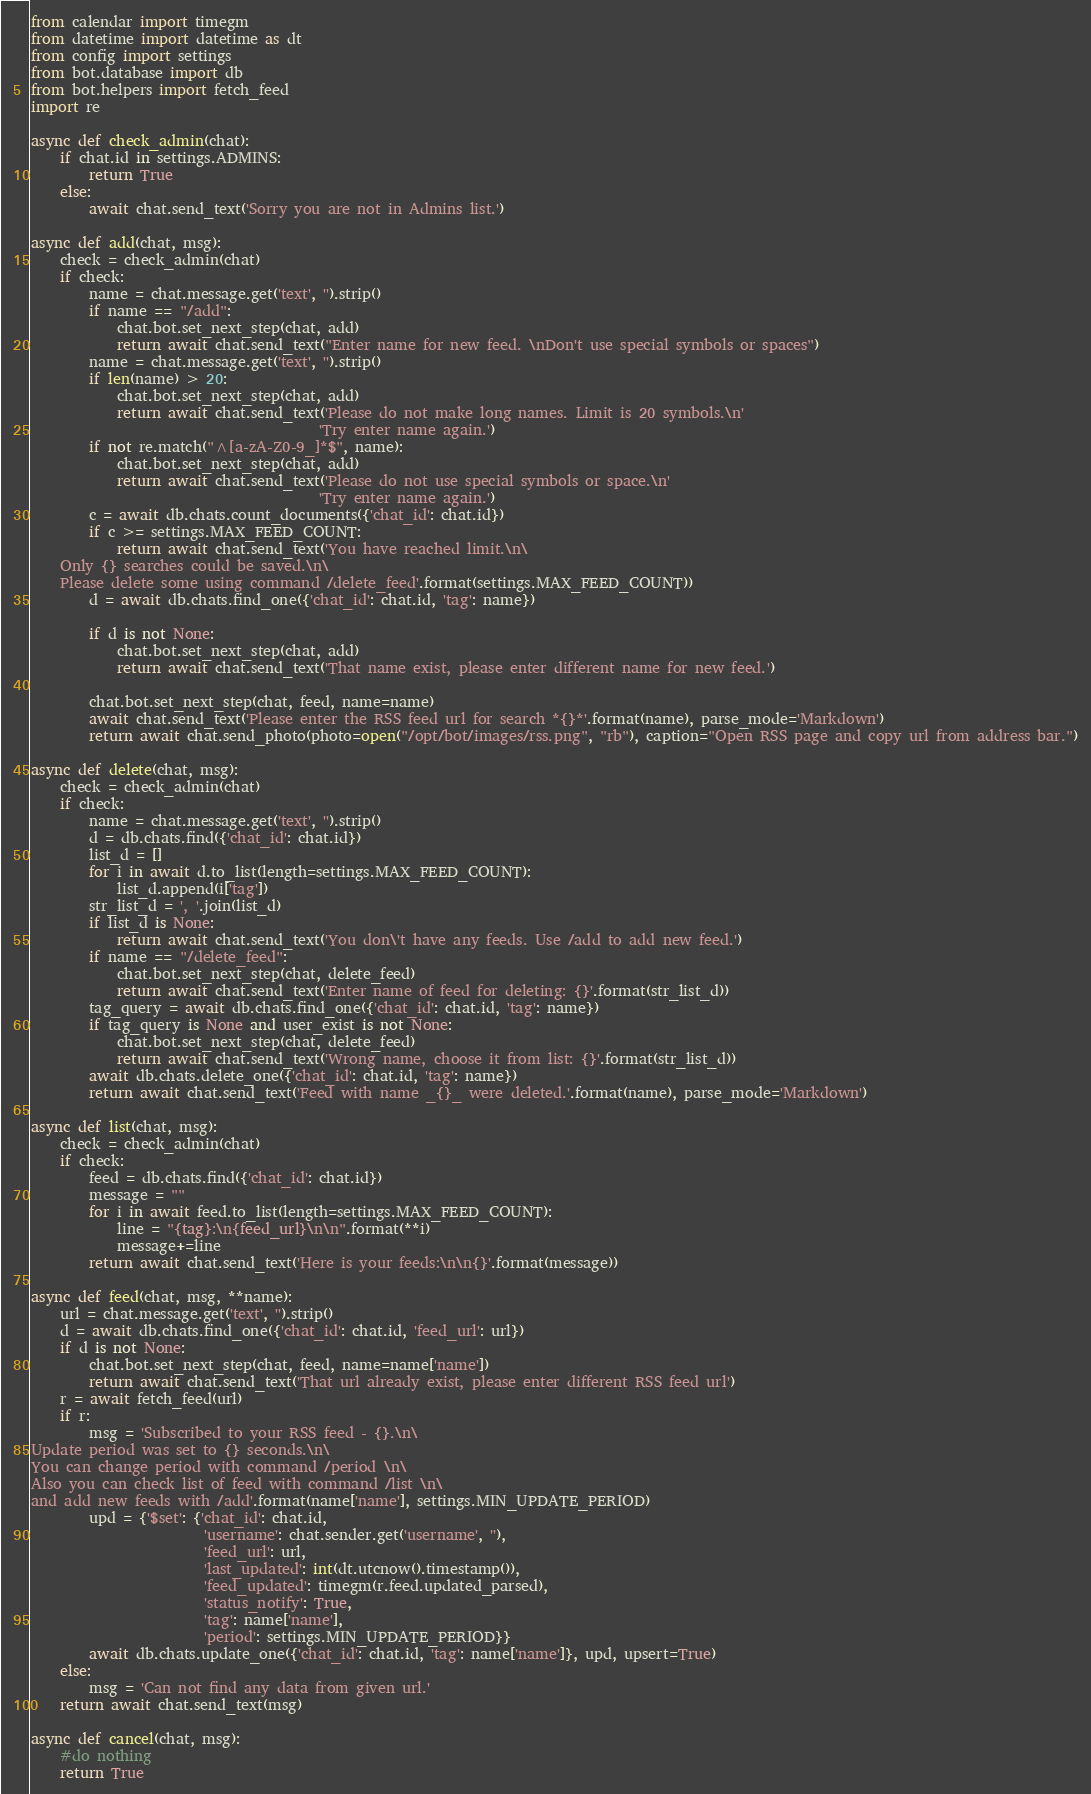<code> <loc_0><loc_0><loc_500><loc_500><_Python_>from calendar import timegm
from datetime import datetime as dt
from config import settings
from bot.database import db
from bot.helpers import fetch_feed
import re

async def check_admin(chat):
    if chat.id in settings.ADMINS:
        return True
    else:
        await chat.send_text('Sorry you are not in Admins list.')

async def add(chat, msg):
    check = check_admin(chat)
    if check:
        name = chat.message.get('text', '').strip()
        if name == "/add":
            chat.bot.set_next_step(chat, add)
            return await chat.send_text("Enter name for new feed. \nDon't use special symbols or spaces")
        name = chat.message.get('text', '').strip()
        if len(name) > 20:
            chat.bot.set_next_step(chat, add)
            return await chat.send_text('Please do not make long names. Limit is 20 symbols.\n'
                                        'Try enter name again.')
        if not re.match("^[a-zA-Z0-9_]*$", name):
            chat.bot.set_next_step(chat, add)
            return await chat.send_text('Please do not use special symbols or space.\n'
                                        'Try enter name again.')
        c = await db.chats.count_documents({'chat_id': chat.id})
        if c >= settings.MAX_FEED_COUNT:
            return await chat.send_text('You have reached limit.\n\
    Only {} searches could be saved.\n\
    Please delete some using command /delete_feed'.format(settings.MAX_FEED_COUNT))
        d = await db.chats.find_one({'chat_id': chat.id, 'tag': name})

        if d is not None:
            chat.bot.set_next_step(chat, add)
            return await chat.send_text('That name exist, please enter different name for new feed.')

        chat.bot.set_next_step(chat, feed, name=name)
        await chat.send_text('Please enter the RSS feed url for search *{}*'.format(name), parse_mode='Markdown')
        return await chat.send_photo(photo=open("/opt/bot/images/rss.png", "rb"), caption="Open RSS page and copy url from address bar.")

async def delete(chat, msg):
    check = check_admin(chat)
    if check:
        name = chat.message.get('text', '').strip()
        d = db.chats.find({'chat_id': chat.id})
        list_d = []
        for i in await d.to_list(length=settings.MAX_FEED_COUNT):
            list_d.append(i['tag'])
        str_list_d = ', '.join(list_d)
        if list_d is None:
            return await chat.send_text('You don\'t have any feeds. Use /add to add new feed.')
        if name == "/delete_feed":
            chat.bot.set_next_step(chat, delete_feed)
            return await chat.send_text('Enter name of feed for deleting: {}'.format(str_list_d))
        tag_query = await db.chats.find_one({'chat_id': chat.id, 'tag': name})
        if tag_query is None and user_exist is not None:
            chat.bot.set_next_step(chat, delete_feed)
            return await chat.send_text('Wrong name, choose it from list: {}'.format(str_list_d))
        await db.chats.delete_one({'chat_id': chat.id, 'tag': name})
        return await chat.send_text('Feed with name _{}_ were deleted.'.format(name), parse_mode='Markdown')

async def list(chat, msg):
    check = check_admin(chat)
    if check:
        feed = db.chats.find({'chat_id': chat.id})
        message = ""
        for i in await feed.to_list(length=settings.MAX_FEED_COUNT):
            line = "{tag}:\n{feed_url}\n\n".format(**i)
            message+=line
        return await chat.send_text('Here is your feeds:\n\n{}'.format(message))

async def feed(chat, msg, **name):
    url = chat.message.get('text', '').strip()
    d = await db.chats.find_one({'chat_id': chat.id, 'feed_url': url})
    if d is not None:
        chat.bot.set_next_step(chat, feed, name=name['name'])
        return await chat.send_text('That url already exist, please enter different RSS feed url')
    r = await fetch_feed(url)
    if r:
        msg = 'Subscribed to your RSS feed - {}.\n\
Update period was set to {} seconds.\n\
You can change period with command /period \n\
Also you can check list of feed with command /list \n\
and add new feeds with /add'.format(name['name'], settings.MIN_UPDATE_PERIOD)
        upd = {'$set': {'chat_id': chat.id,
                        'username': chat.sender.get('username', ''),
                        'feed_url': url,
                        'last_updated': int(dt.utcnow().timestamp()),
                        'feed_updated': timegm(r.feed.updated_parsed),
                        'status_notify': True,
                        'tag': name['name'],
                        'period': settings.MIN_UPDATE_PERIOD}}
        await db.chats.update_one({'chat_id': chat.id, 'tag': name['name']}, upd, upsert=True)
    else:
        msg = 'Can not find any data from given url.'
    return await chat.send_text(msg)

async def cancel(chat, msg):
    #do nothing
    return True</code> 